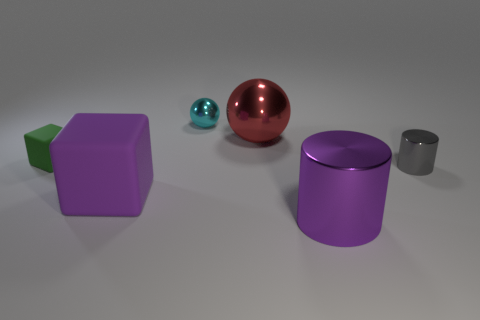What is the size of the cylinder that is the same color as the large matte thing?
Give a very brief answer. Large. How many other objects are there of the same shape as the big purple metal object?
Ensure brevity in your answer.  1. How many red things are metal things or metal cylinders?
Make the answer very short. 1. How many rubber things are left of the big purple rubber object?
Your answer should be very brief. 1. Is the number of large red matte balls greater than the number of big purple metal cylinders?
Your answer should be compact. No. The purple object that is to the left of the cylinder in front of the tiny gray metallic thing is what shape?
Your response must be concise. Cube. Is the color of the tiny shiny cylinder the same as the small matte thing?
Provide a succinct answer. No. Are there more small shiny spheres in front of the small cyan metal sphere than small objects?
Your answer should be compact. No. What number of big purple cylinders are behind the tiny thing to the right of the purple cylinder?
Keep it short and to the point. 0. Does the small thing behind the big ball have the same material as the object that is on the right side of the purple metal thing?
Provide a short and direct response. Yes. 